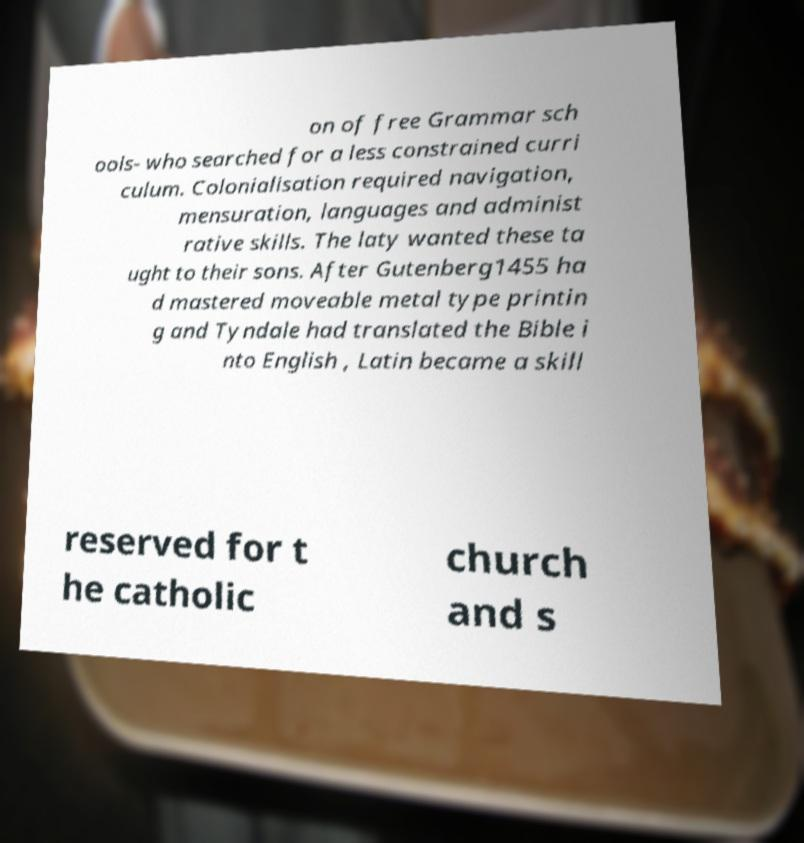Can you read and provide the text displayed in the image?This photo seems to have some interesting text. Can you extract and type it out for me? on of free Grammar sch ools- who searched for a less constrained curri culum. Colonialisation required navigation, mensuration, languages and administ rative skills. The laty wanted these ta ught to their sons. After Gutenberg1455 ha d mastered moveable metal type printin g and Tyndale had translated the Bible i nto English , Latin became a skill reserved for t he catholic church and s 